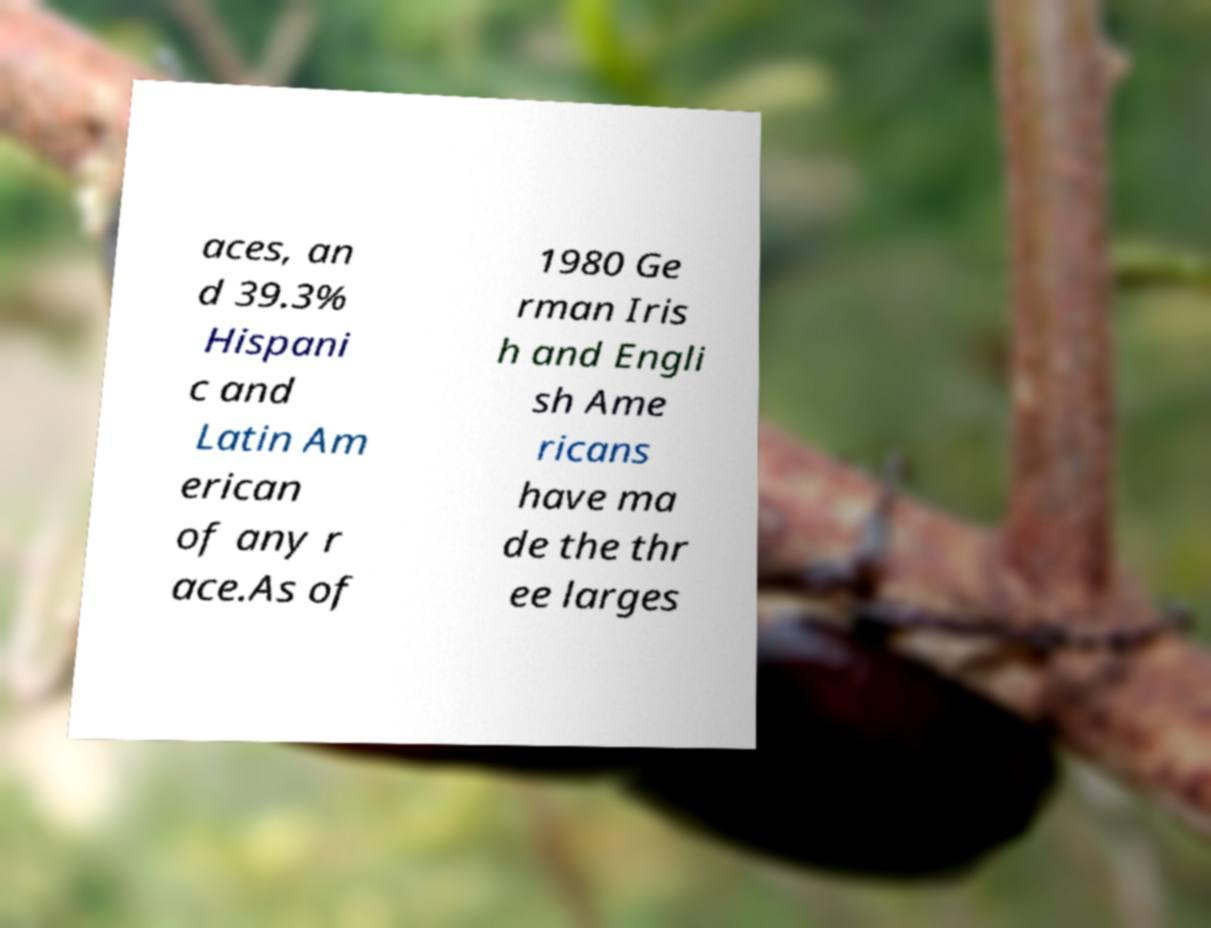For documentation purposes, I need the text within this image transcribed. Could you provide that? aces, an d 39.3% Hispani c and Latin Am erican of any r ace.As of 1980 Ge rman Iris h and Engli sh Ame ricans have ma de the thr ee larges 